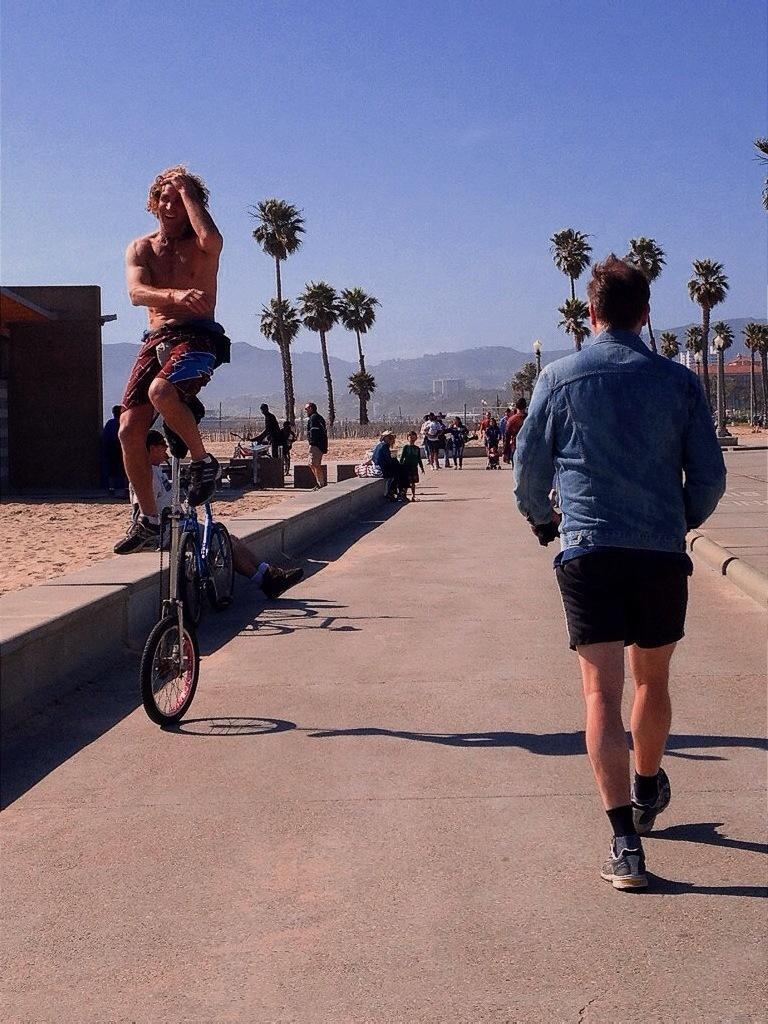Could you give a brief overview of what you see in this image? In the left side a man is cycling a mono cycle in the right side a man is walking, he wore a jean shirt, black color short. There are boundaries on either side of this road, at the top it's a blue color sky. 